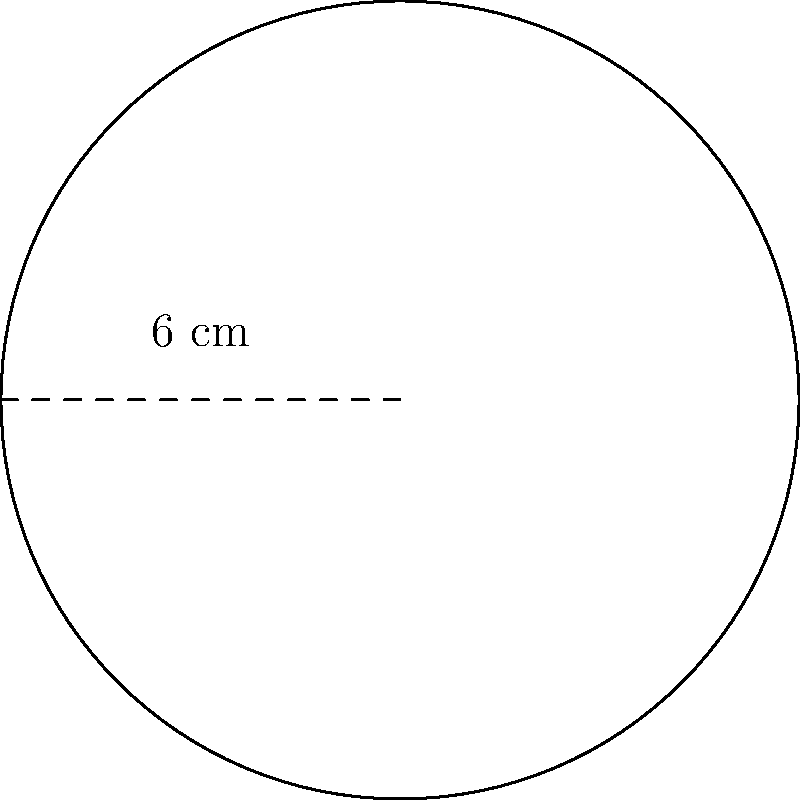As part of your zero-waste initiative, you're designing a circular logo for eco-friendly packaging. The logo has a diameter of 6 cm. What is the area of the circular logo in square centimeters? To calculate the area of a circular logo, we'll follow these steps:

1. Identify the given information:
   - Diameter of the logo = 6 cm

2. Calculate the radius:
   Radius = Diameter ÷ 2
   Radius = 6 cm ÷ 2 = 3 cm

3. Use the formula for the area of a circle:
   Area = π × r²
   Where r is the radius

4. Substitute the values:
   Area = π × (3 cm)²
   Area = π × 9 cm²

5. Calculate the final result:
   Area ≈ 28.27 cm²

Therefore, the area of the circular logo is approximately 28.27 square centimeters.
Answer: 28.27 cm² 